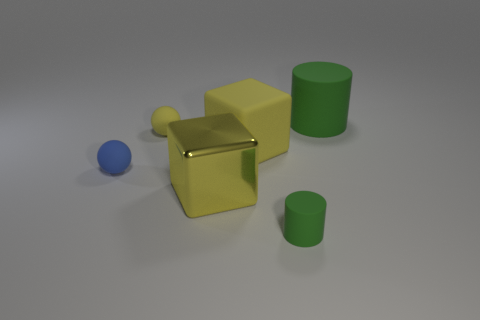What aspect of this image suggests that it might be a computer-generated rendering? Several clues indicate this might be a computer-generated rendering: the overly smooth surfaces of the objects, the perfection in object shapes, the uniformity of the colors, and the precise but simple shadows lacking the complexity typically seen in real-world lighting conditions. Does anything in this image provide a sense of scale or indicate how large these objects might be? In the absence of familiar objects or reference points, there's nothing in the image that definitively indicates the scale or the size of the objects. 